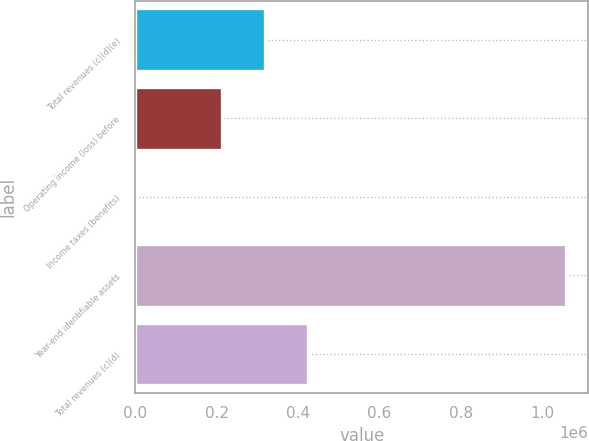Convert chart. <chart><loc_0><loc_0><loc_500><loc_500><bar_chart><fcel>Total revenues (c)(d)(e)<fcel>Operating income (loss) before<fcel>Income taxes (benefits)<fcel>Year-end identifiable assets<fcel>Total revenues (c)(d)<nl><fcel>319170<fcel>213265<fcel>1455<fcel>1.0605e+06<fcel>425075<nl></chart> 